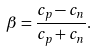Convert formula to latex. <formula><loc_0><loc_0><loc_500><loc_500>\beta = \frac { c _ { p } - c _ { n } } { c _ { p } + c _ { n } } .</formula> 